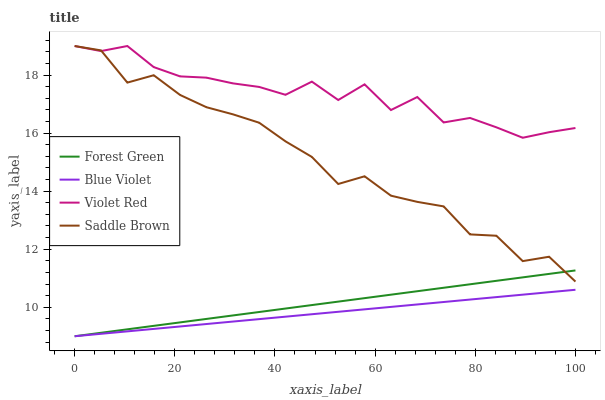Does Blue Violet have the minimum area under the curve?
Answer yes or no. Yes. Does Violet Red have the maximum area under the curve?
Answer yes or no. Yes. Does Violet Red have the minimum area under the curve?
Answer yes or no. No. Does Blue Violet have the maximum area under the curve?
Answer yes or no. No. Is Blue Violet the smoothest?
Answer yes or no. Yes. Is Saddle Brown the roughest?
Answer yes or no. Yes. Is Violet Red the smoothest?
Answer yes or no. No. Is Violet Red the roughest?
Answer yes or no. No. Does Forest Green have the lowest value?
Answer yes or no. Yes. Does Violet Red have the lowest value?
Answer yes or no. No. Does Saddle Brown have the highest value?
Answer yes or no. Yes. Does Blue Violet have the highest value?
Answer yes or no. No. Is Blue Violet less than Violet Red?
Answer yes or no. Yes. Is Violet Red greater than Blue Violet?
Answer yes or no. Yes. Does Blue Violet intersect Forest Green?
Answer yes or no. Yes. Is Blue Violet less than Forest Green?
Answer yes or no. No. Is Blue Violet greater than Forest Green?
Answer yes or no. No. Does Blue Violet intersect Violet Red?
Answer yes or no. No. 